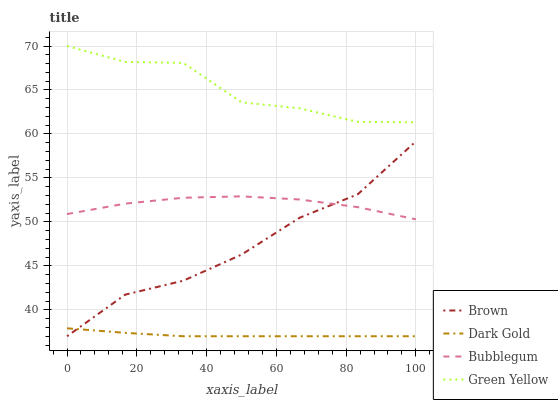Does Dark Gold have the minimum area under the curve?
Answer yes or no. Yes. Does Green Yellow have the maximum area under the curve?
Answer yes or no. Yes. Does Bubblegum have the minimum area under the curve?
Answer yes or no. No. Does Bubblegum have the maximum area under the curve?
Answer yes or no. No. Is Dark Gold the smoothest?
Answer yes or no. Yes. Is Green Yellow the roughest?
Answer yes or no. Yes. Is Bubblegum the smoothest?
Answer yes or no. No. Is Bubblegum the roughest?
Answer yes or no. No. Does Bubblegum have the lowest value?
Answer yes or no. No. Does Green Yellow have the highest value?
Answer yes or no. Yes. Does Bubblegum have the highest value?
Answer yes or no. No. Is Dark Gold less than Bubblegum?
Answer yes or no. Yes. Is Bubblegum greater than Dark Gold?
Answer yes or no. Yes. Does Bubblegum intersect Brown?
Answer yes or no. Yes. Is Bubblegum less than Brown?
Answer yes or no. No. Is Bubblegum greater than Brown?
Answer yes or no. No. Does Dark Gold intersect Bubblegum?
Answer yes or no. No. 